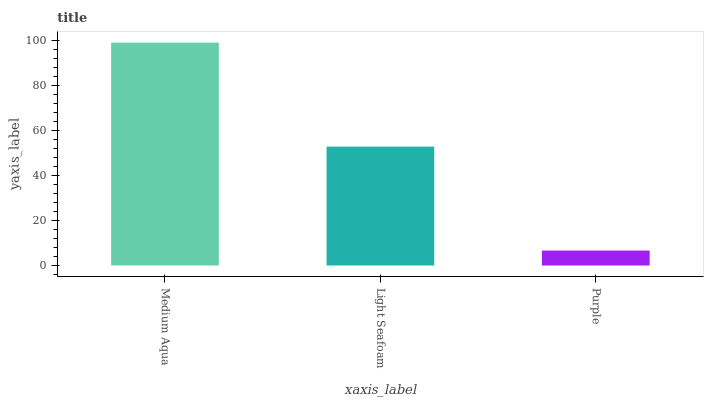Is Purple the minimum?
Answer yes or no. Yes. Is Medium Aqua the maximum?
Answer yes or no. Yes. Is Light Seafoam the minimum?
Answer yes or no. No. Is Light Seafoam the maximum?
Answer yes or no. No. Is Medium Aqua greater than Light Seafoam?
Answer yes or no. Yes. Is Light Seafoam less than Medium Aqua?
Answer yes or no. Yes. Is Light Seafoam greater than Medium Aqua?
Answer yes or no. No. Is Medium Aqua less than Light Seafoam?
Answer yes or no. No. Is Light Seafoam the high median?
Answer yes or no. Yes. Is Light Seafoam the low median?
Answer yes or no. Yes. Is Purple the high median?
Answer yes or no. No. Is Purple the low median?
Answer yes or no. No. 